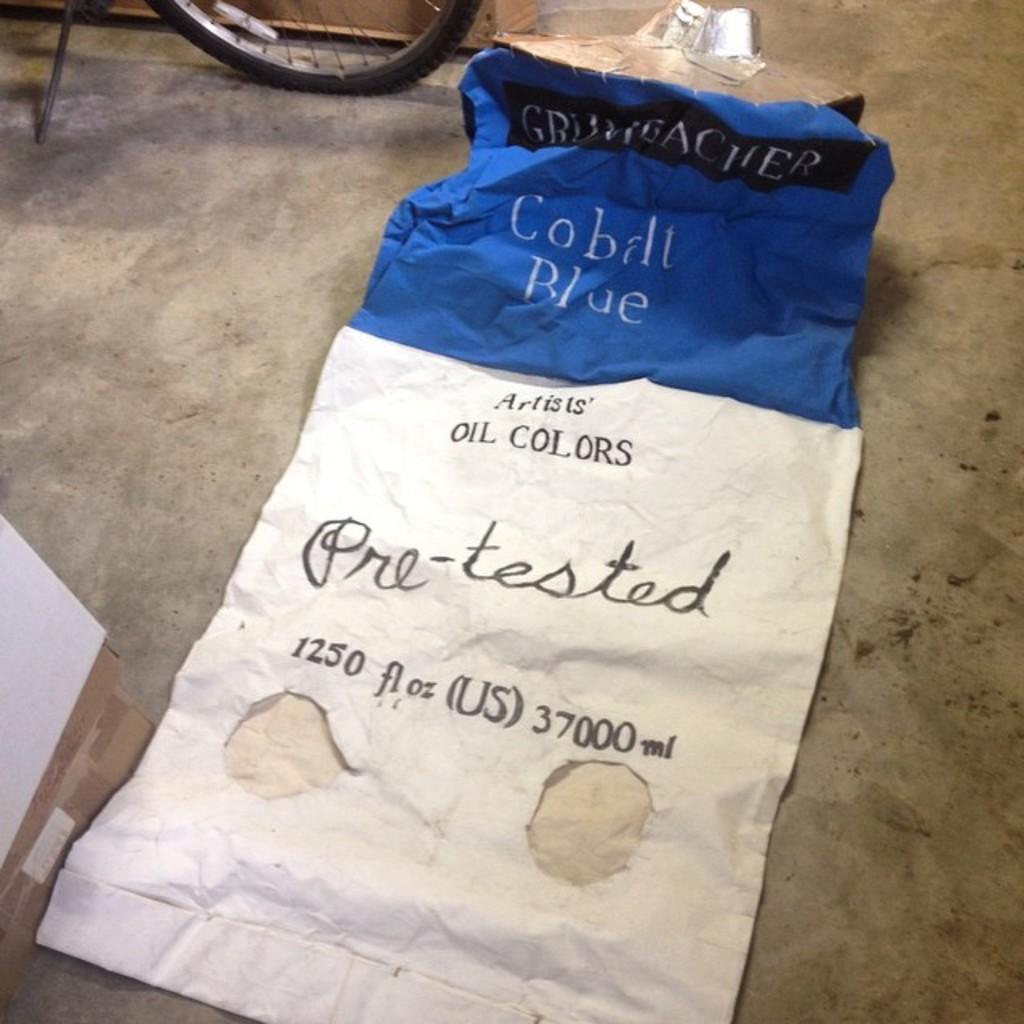Could you give a brief overview of what you see in this image? In this image there is ground towards the bottom of the image, there is a cloth on the ground, there is text on the cloth, there is a number on the cloth, there is an object towards the left of the image, there is a tire towards the top of the image, there are objects towards the top of the image. 